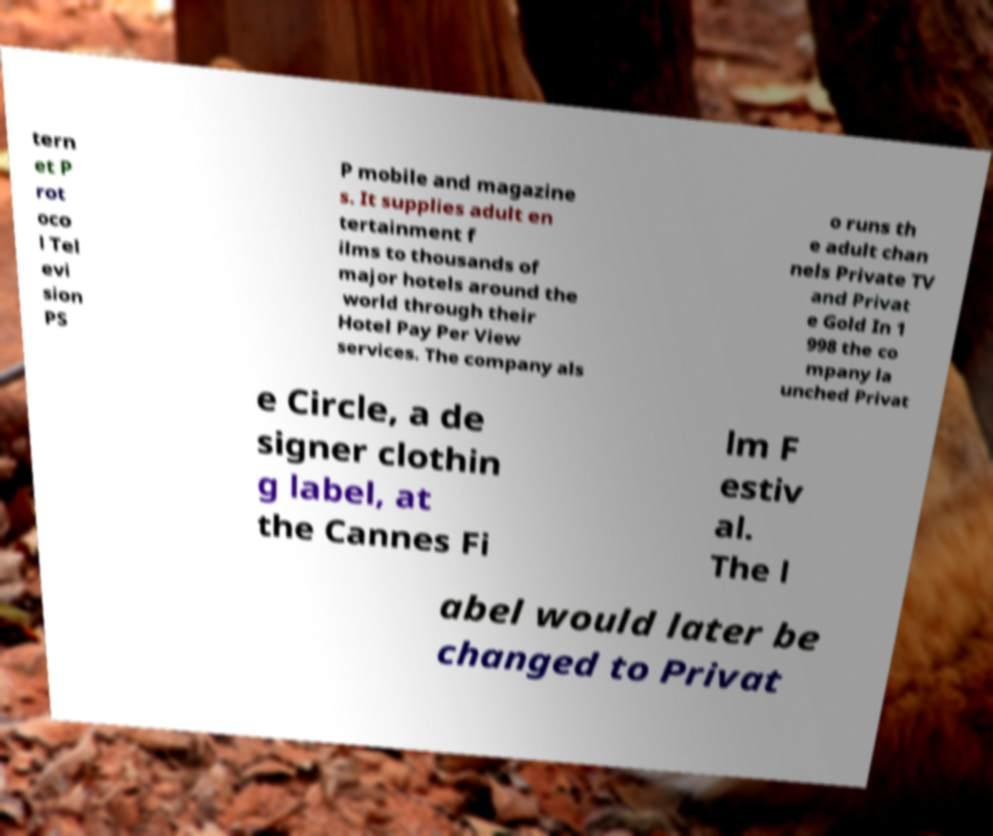Can you read and provide the text displayed in the image?This photo seems to have some interesting text. Can you extract and type it out for me? tern et P rot oco l Tel evi sion PS P mobile and magazine s. It supplies adult en tertainment f ilms to thousands of major hotels around the world through their Hotel Pay Per View services. The company als o runs th e adult chan nels Private TV and Privat e Gold In 1 998 the co mpany la unched Privat e Circle, a de signer clothin g label, at the Cannes Fi lm F estiv al. The l abel would later be changed to Privat 